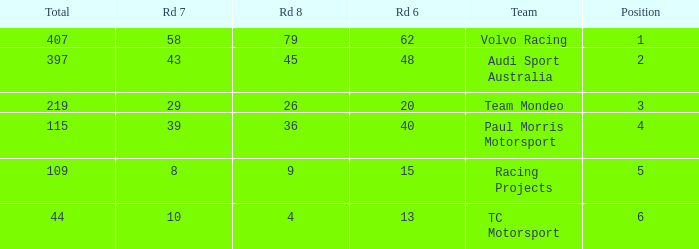What is the sum of total values for Rd 7 less than 8? None. 